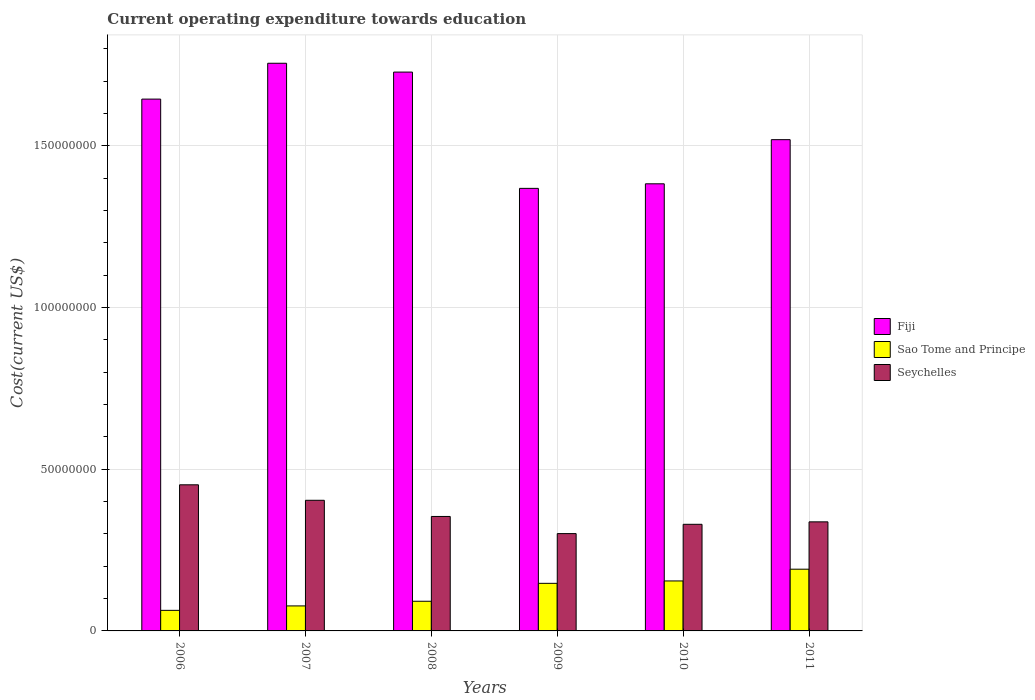How many different coloured bars are there?
Provide a succinct answer. 3. Are the number of bars per tick equal to the number of legend labels?
Your response must be concise. Yes. How many bars are there on the 1st tick from the left?
Give a very brief answer. 3. What is the expenditure towards education in Fiji in 2007?
Your answer should be compact. 1.76e+08. Across all years, what is the maximum expenditure towards education in Sao Tome and Principe?
Make the answer very short. 1.91e+07. Across all years, what is the minimum expenditure towards education in Fiji?
Keep it short and to the point. 1.37e+08. In which year was the expenditure towards education in Seychelles maximum?
Ensure brevity in your answer.  2006. In which year was the expenditure towards education in Seychelles minimum?
Provide a short and direct response. 2009. What is the total expenditure towards education in Seychelles in the graph?
Offer a terse response. 2.18e+08. What is the difference between the expenditure towards education in Fiji in 2006 and that in 2011?
Keep it short and to the point. 1.25e+07. What is the difference between the expenditure towards education in Seychelles in 2010 and the expenditure towards education in Fiji in 2009?
Offer a very short reply. -1.04e+08. What is the average expenditure towards education in Sao Tome and Principe per year?
Ensure brevity in your answer.  1.21e+07. In the year 2011, what is the difference between the expenditure towards education in Sao Tome and Principe and expenditure towards education in Fiji?
Offer a very short reply. -1.33e+08. In how many years, is the expenditure towards education in Seychelles greater than 100000000 US$?
Offer a very short reply. 0. What is the ratio of the expenditure towards education in Sao Tome and Principe in 2009 to that in 2011?
Offer a terse response. 0.77. Is the expenditure towards education in Seychelles in 2007 less than that in 2009?
Provide a succinct answer. No. Is the difference between the expenditure towards education in Sao Tome and Principe in 2007 and 2011 greater than the difference between the expenditure towards education in Fiji in 2007 and 2011?
Make the answer very short. No. What is the difference between the highest and the second highest expenditure towards education in Seychelles?
Ensure brevity in your answer.  4.79e+06. What is the difference between the highest and the lowest expenditure towards education in Sao Tome and Principe?
Offer a very short reply. 1.27e+07. In how many years, is the expenditure towards education in Fiji greater than the average expenditure towards education in Fiji taken over all years?
Ensure brevity in your answer.  3. What does the 3rd bar from the left in 2006 represents?
Offer a terse response. Seychelles. What does the 3rd bar from the right in 2009 represents?
Offer a very short reply. Fiji. Is it the case that in every year, the sum of the expenditure towards education in Seychelles and expenditure towards education in Sao Tome and Principe is greater than the expenditure towards education in Fiji?
Provide a short and direct response. No. Are all the bars in the graph horizontal?
Ensure brevity in your answer.  No. Does the graph contain any zero values?
Make the answer very short. No. Does the graph contain grids?
Offer a very short reply. Yes. Where does the legend appear in the graph?
Your response must be concise. Center right. How are the legend labels stacked?
Offer a very short reply. Vertical. What is the title of the graph?
Keep it short and to the point. Current operating expenditure towards education. What is the label or title of the Y-axis?
Offer a very short reply. Cost(current US$). What is the Cost(current US$) of Fiji in 2006?
Offer a very short reply. 1.64e+08. What is the Cost(current US$) of Sao Tome and Principe in 2006?
Provide a short and direct response. 6.36e+06. What is the Cost(current US$) in Seychelles in 2006?
Your response must be concise. 4.52e+07. What is the Cost(current US$) of Fiji in 2007?
Your answer should be compact. 1.76e+08. What is the Cost(current US$) of Sao Tome and Principe in 2007?
Ensure brevity in your answer.  7.73e+06. What is the Cost(current US$) of Seychelles in 2007?
Provide a short and direct response. 4.04e+07. What is the Cost(current US$) in Fiji in 2008?
Your answer should be very brief. 1.73e+08. What is the Cost(current US$) of Sao Tome and Principe in 2008?
Your answer should be very brief. 9.17e+06. What is the Cost(current US$) of Seychelles in 2008?
Give a very brief answer. 3.54e+07. What is the Cost(current US$) in Fiji in 2009?
Offer a very short reply. 1.37e+08. What is the Cost(current US$) in Sao Tome and Principe in 2009?
Offer a very short reply. 1.47e+07. What is the Cost(current US$) in Seychelles in 2009?
Offer a very short reply. 3.01e+07. What is the Cost(current US$) of Fiji in 2010?
Make the answer very short. 1.38e+08. What is the Cost(current US$) of Sao Tome and Principe in 2010?
Give a very brief answer. 1.55e+07. What is the Cost(current US$) in Seychelles in 2010?
Your response must be concise. 3.30e+07. What is the Cost(current US$) in Fiji in 2011?
Give a very brief answer. 1.52e+08. What is the Cost(current US$) of Sao Tome and Principe in 2011?
Ensure brevity in your answer.  1.91e+07. What is the Cost(current US$) of Seychelles in 2011?
Ensure brevity in your answer.  3.37e+07. Across all years, what is the maximum Cost(current US$) of Fiji?
Offer a terse response. 1.76e+08. Across all years, what is the maximum Cost(current US$) in Sao Tome and Principe?
Your response must be concise. 1.91e+07. Across all years, what is the maximum Cost(current US$) in Seychelles?
Offer a terse response. 4.52e+07. Across all years, what is the minimum Cost(current US$) of Fiji?
Your answer should be very brief. 1.37e+08. Across all years, what is the minimum Cost(current US$) of Sao Tome and Principe?
Make the answer very short. 6.36e+06. Across all years, what is the minimum Cost(current US$) of Seychelles?
Ensure brevity in your answer.  3.01e+07. What is the total Cost(current US$) in Fiji in the graph?
Provide a succinct answer. 9.40e+08. What is the total Cost(current US$) in Sao Tome and Principe in the graph?
Ensure brevity in your answer.  7.25e+07. What is the total Cost(current US$) of Seychelles in the graph?
Your response must be concise. 2.18e+08. What is the difference between the Cost(current US$) of Fiji in 2006 and that in 2007?
Your response must be concise. -1.11e+07. What is the difference between the Cost(current US$) in Sao Tome and Principe in 2006 and that in 2007?
Provide a short and direct response. -1.38e+06. What is the difference between the Cost(current US$) of Seychelles in 2006 and that in 2007?
Offer a terse response. 4.79e+06. What is the difference between the Cost(current US$) of Fiji in 2006 and that in 2008?
Your answer should be very brief. -8.36e+06. What is the difference between the Cost(current US$) in Sao Tome and Principe in 2006 and that in 2008?
Your answer should be compact. -2.81e+06. What is the difference between the Cost(current US$) in Seychelles in 2006 and that in 2008?
Keep it short and to the point. 9.79e+06. What is the difference between the Cost(current US$) in Fiji in 2006 and that in 2009?
Offer a terse response. 2.76e+07. What is the difference between the Cost(current US$) in Sao Tome and Principe in 2006 and that in 2009?
Your answer should be compact. -8.36e+06. What is the difference between the Cost(current US$) in Seychelles in 2006 and that in 2009?
Make the answer very short. 1.51e+07. What is the difference between the Cost(current US$) of Fiji in 2006 and that in 2010?
Give a very brief answer. 2.62e+07. What is the difference between the Cost(current US$) in Sao Tome and Principe in 2006 and that in 2010?
Offer a very short reply. -9.09e+06. What is the difference between the Cost(current US$) of Seychelles in 2006 and that in 2010?
Your response must be concise. 1.22e+07. What is the difference between the Cost(current US$) of Fiji in 2006 and that in 2011?
Keep it short and to the point. 1.25e+07. What is the difference between the Cost(current US$) in Sao Tome and Principe in 2006 and that in 2011?
Your answer should be very brief. -1.27e+07. What is the difference between the Cost(current US$) in Seychelles in 2006 and that in 2011?
Give a very brief answer. 1.15e+07. What is the difference between the Cost(current US$) in Fiji in 2007 and that in 2008?
Give a very brief answer. 2.73e+06. What is the difference between the Cost(current US$) in Sao Tome and Principe in 2007 and that in 2008?
Give a very brief answer. -1.44e+06. What is the difference between the Cost(current US$) of Seychelles in 2007 and that in 2008?
Offer a very short reply. 5.00e+06. What is the difference between the Cost(current US$) in Fiji in 2007 and that in 2009?
Keep it short and to the point. 3.87e+07. What is the difference between the Cost(current US$) in Sao Tome and Principe in 2007 and that in 2009?
Offer a very short reply. -6.98e+06. What is the difference between the Cost(current US$) in Seychelles in 2007 and that in 2009?
Offer a very short reply. 1.03e+07. What is the difference between the Cost(current US$) in Fiji in 2007 and that in 2010?
Your answer should be compact. 3.73e+07. What is the difference between the Cost(current US$) in Sao Tome and Principe in 2007 and that in 2010?
Provide a short and direct response. -7.72e+06. What is the difference between the Cost(current US$) of Seychelles in 2007 and that in 2010?
Give a very brief answer. 7.42e+06. What is the difference between the Cost(current US$) in Fiji in 2007 and that in 2011?
Your response must be concise. 2.36e+07. What is the difference between the Cost(current US$) in Sao Tome and Principe in 2007 and that in 2011?
Ensure brevity in your answer.  -1.14e+07. What is the difference between the Cost(current US$) of Seychelles in 2007 and that in 2011?
Keep it short and to the point. 6.67e+06. What is the difference between the Cost(current US$) in Fiji in 2008 and that in 2009?
Offer a very short reply. 3.60e+07. What is the difference between the Cost(current US$) in Sao Tome and Principe in 2008 and that in 2009?
Ensure brevity in your answer.  -5.54e+06. What is the difference between the Cost(current US$) of Seychelles in 2008 and that in 2009?
Give a very brief answer. 5.30e+06. What is the difference between the Cost(current US$) in Fiji in 2008 and that in 2010?
Keep it short and to the point. 3.45e+07. What is the difference between the Cost(current US$) of Sao Tome and Principe in 2008 and that in 2010?
Provide a short and direct response. -6.28e+06. What is the difference between the Cost(current US$) of Seychelles in 2008 and that in 2010?
Keep it short and to the point. 2.42e+06. What is the difference between the Cost(current US$) of Fiji in 2008 and that in 2011?
Offer a very short reply. 2.09e+07. What is the difference between the Cost(current US$) of Sao Tome and Principe in 2008 and that in 2011?
Provide a succinct answer. -9.92e+06. What is the difference between the Cost(current US$) of Seychelles in 2008 and that in 2011?
Give a very brief answer. 1.67e+06. What is the difference between the Cost(current US$) of Fiji in 2009 and that in 2010?
Ensure brevity in your answer.  -1.41e+06. What is the difference between the Cost(current US$) of Sao Tome and Principe in 2009 and that in 2010?
Your answer should be compact. -7.37e+05. What is the difference between the Cost(current US$) of Seychelles in 2009 and that in 2010?
Make the answer very short. -2.88e+06. What is the difference between the Cost(current US$) in Fiji in 2009 and that in 2011?
Provide a short and direct response. -1.51e+07. What is the difference between the Cost(current US$) of Sao Tome and Principe in 2009 and that in 2011?
Offer a very short reply. -4.37e+06. What is the difference between the Cost(current US$) of Seychelles in 2009 and that in 2011?
Offer a very short reply. -3.63e+06. What is the difference between the Cost(current US$) in Fiji in 2010 and that in 2011?
Provide a succinct answer. -1.36e+07. What is the difference between the Cost(current US$) of Sao Tome and Principe in 2010 and that in 2011?
Provide a succinct answer. -3.63e+06. What is the difference between the Cost(current US$) in Seychelles in 2010 and that in 2011?
Provide a succinct answer. -7.57e+05. What is the difference between the Cost(current US$) in Fiji in 2006 and the Cost(current US$) in Sao Tome and Principe in 2007?
Your response must be concise. 1.57e+08. What is the difference between the Cost(current US$) of Fiji in 2006 and the Cost(current US$) of Seychelles in 2007?
Provide a succinct answer. 1.24e+08. What is the difference between the Cost(current US$) of Sao Tome and Principe in 2006 and the Cost(current US$) of Seychelles in 2007?
Make the answer very short. -3.40e+07. What is the difference between the Cost(current US$) in Fiji in 2006 and the Cost(current US$) in Sao Tome and Principe in 2008?
Your response must be concise. 1.55e+08. What is the difference between the Cost(current US$) of Fiji in 2006 and the Cost(current US$) of Seychelles in 2008?
Keep it short and to the point. 1.29e+08. What is the difference between the Cost(current US$) of Sao Tome and Principe in 2006 and the Cost(current US$) of Seychelles in 2008?
Keep it short and to the point. -2.90e+07. What is the difference between the Cost(current US$) of Fiji in 2006 and the Cost(current US$) of Sao Tome and Principe in 2009?
Ensure brevity in your answer.  1.50e+08. What is the difference between the Cost(current US$) of Fiji in 2006 and the Cost(current US$) of Seychelles in 2009?
Your response must be concise. 1.34e+08. What is the difference between the Cost(current US$) in Sao Tome and Principe in 2006 and the Cost(current US$) in Seychelles in 2009?
Give a very brief answer. -2.37e+07. What is the difference between the Cost(current US$) in Fiji in 2006 and the Cost(current US$) in Sao Tome and Principe in 2010?
Ensure brevity in your answer.  1.49e+08. What is the difference between the Cost(current US$) in Fiji in 2006 and the Cost(current US$) in Seychelles in 2010?
Offer a very short reply. 1.31e+08. What is the difference between the Cost(current US$) of Sao Tome and Principe in 2006 and the Cost(current US$) of Seychelles in 2010?
Offer a very short reply. -2.66e+07. What is the difference between the Cost(current US$) of Fiji in 2006 and the Cost(current US$) of Sao Tome and Principe in 2011?
Your answer should be compact. 1.45e+08. What is the difference between the Cost(current US$) of Fiji in 2006 and the Cost(current US$) of Seychelles in 2011?
Ensure brevity in your answer.  1.31e+08. What is the difference between the Cost(current US$) in Sao Tome and Principe in 2006 and the Cost(current US$) in Seychelles in 2011?
Ensure brevity in your answer.  -2.74e+07. What is the difference between the Cost(current US$) in Fiji in 2007 and the Cost(current US$) in Sao Tome and Principe in 2008?
Make the answer very short. 1.66e+08. What is the difference between the Cost(current US$) of Fiji in 2007 and the Cost(current US$) of Seychelles in 2008?
Your answer should be very brief. 1.40e+08. What is the difference between the Cost(current US$) in Sao Tome and Principe in 2007 and the Cost(current US$) in Seychelles in 2008?
Keep it short and to the point. -2.77e+07. What is the difference between the Cost(current US$) of Fiji in 2007 and the Cost(current US$) of Sao Tome and Principe in 2009?
Provide a short and direct response. 1.61e+08. What is the difference between the Cost(current US$) of Fiji in 2007 and the Cost(current US$) of Seychelles in 2009?
Make the answer very short. 1.45e+08. What is the difference between the Cost(current US$) in Sao Tome and Principe in 2007 and the Cost(current US$) in Seychelles in 2009?
Ensure brevity in your answer.  -2.24e+07. What is the difference between the Cost(current US$) in Fiji in 2007 and the Cost(current US$) in Sao Tome and Principe in 2010?
Your answer should be compact. 1.60e+08. What is the difference between the Cost(current US$) of Fiji in 2007 and the Cost(current US$) of Seychelles in 2010?
Keep it short and to the point. 1.43e+08. What is the difference between the Cost(current US$) in Sao Tome and Principe in 2007 and the Cost(current US$) in Seychelles in 2010?
Your answer should be very brief. -2.52e+07. What is the difference between the Cost(current US$) of Fiji in 2007 and the Cost(current US$) of Sao Tome and Principe in 2011?
Your answer should be compact. 1.56e+08. What is the difference between the Cost(current US$) of Fiji in 2007 and the Cost(current US$) of Seychelles in 2011?
Your answer should be compact. 1.42e+08. What is the difference between the Cost(current US$) in Sao Tome and Principe in 2007 and the Cost(current US$) in Seychelles in 2011?
Offer a terse response. -2.60e+07. What is the difference between the Cost(current US$) in Fiji in 2008 and the Cost(current US$) in Sao Tome and Principe in 2009?
Provide a short and direct response. 1.58e+08. What is the difference between the Cost(current US$) in Fiji in 2008 and the Cost(current US$) in Seychelles in 2009?
Offer a terse response. 1.43e+08. What is the difference between the Cost(current US$) in Sao Tome and Principe in 2008 and the Cost(current US$) in Seychelles in 2009?
Ensure brevity in your answer.  -2.09e+07. What is the difference between the Cost(current US$) in Fiji in 2008 and the Cost(current US$) in Sao Tome and Principe in 2010?
Offer a terse response. 1.57e+08. What is the difference between the Cost(current US$) of Fiji in 2008 and the Cost(current US$) of Seychelles in 2010?
Offer a terse response. 1.40e+08. What is the difference between the Cost(current US$) of Sao Tome and Principe in 2008 and the Cost(current US$) of Seychelles in 2010?
Ensure brevity in your answer.  -2.38e+07. What is the difference between the Cost(current US$) of Fiji in 2008 and the Cost(current US$) of Sao Tome and Principe in 2011?
Give a very brief answer. 1.54e+08. What is the difference between the Cost(current US$) in Fiji in 2008 and the Cost(current US$) in Seychelles in 2011?
Your answer should be compact. 1.39e+08. What is the difference between the Cost(current US$) of Sao Tome and Principe in 2008 and the Cost(current US$) of Seychelles in 2011?
Provide a short and direct response. -2.46e+07. What is the difference between the Cost(current US$) of Fiji in 2009 and the Cost(current US$) of Sao Tome and Principe in 2010?
Your answer should be very brief. 1.21e+08. What is the difference between the Cost(current US$) of Fiji in 2009 and the Cost(current US$) of Seychelles in 2010?
Ensure brevity in your answer.  1.04e+08. What is the difference between the Cost(current US$) of Sao Tome and Principe in 2009 and the Cost(current US$) of Seychelles in 2010?
Your answer should be very brief. -1.83e+07. What is the difference between the Cost(current US$) of Fiji in 2009 and the Cost(current US$) of Sao Tome and Principe in 2011?
Provide a succinct answer. 1.18e+08. What is the difference between the Cost(current US$) in Fiji in 2009 and the Cost(current US$) in Seychelles in 2011?
Provide a short and direct response. 1.03e+08. What is the difference between the Cost(current US$) in Sao Tome and Principe in 2009 and the Cost(current US$) in Seychelles in 2011?
Keep it short and to the point. -1.90e+07. What is the difference between the Cost(current US$) in Fiji in 2010 and the Cost(current US$) in Sao Tome and Principe in 2011?
Your answer should be compact. 1.19e+08. What is the difference between the Cost(current US$) of Fiji in 2010 and the Cost(current US$) of Seychelles in 2011?
Your response must be concise. 1.05e+08. What is the difference between the Cost(current US$) in Sao Tome and Principe in 2010 and the Cost(current US$) in Seychelles in 2011?
Provide a succinct answer. -1.83e+07. What is the average Cost(current US$) of Fiji per year?
Provide a succinct answer. 1.57e+08. What is the average Cost(current US$) of Sao Tome and Principe per year?
Offer a terse response. 1.21e+07. What is the average Cost(current US$) of Seychelles per year?
Give a very brief answer. 3.63e+07. In the year 2006, what is the difference between the Cost(current US$) in Fiji and Cost(current US$) in Sao Tome and Principe?
Your response must be concise. 1.58e+08. In the year 2006, what is the difference between the Cost(current US$) of Fiji and Cost(current US$) of Seychelles?
Offer a very short reply. 1.19e+08. In the year 2006, what is the difference between the Cost(current US$) of Sao Tome and Principe and Cost(current US$) of Seychelles?
Make the answer very short. -3.88e+07. In the year 2007, what is the difference between the Cost(current US$) in Fiji and Cost(current US$) in Sao Tome and Principe?
Your answer should be very brief. 1.68e+08. In the year 2007, what is the difference between the Cost(current US$) in Fiji and Cost(current US$) in Seychelles?
Your answer should be very brief. 1.35e+08. In the year 2007, what is the difference between the Cost(current US$) of Sao Tome and Principe and Cost(current US$) of Seychelles?
Your answer should be very brief. -3.27e+07. In the year 2008, what is the difference between the Cost(current US$) in Fiji and Cost(current US$) in Sao Tome and Principe?
Your answer should be compact. 1.64e+08. In the year 2008, what is the difference between the Cost(current US$) in Fiji and Cost(current US$) in Seychelles?
Your response must be concise. 1.37e+08. In the year 2008, what is the difference between the Cost(current US$) in Sao Tome and Principe and Cost(current US$) in Seychelles?
Offer a very short reply. -2.62e+07. In the year 2009, what is the difference between the Cost(current US$) in Fiji and Cost(current US$) in Sao Tome and Principe?
Make the answer very short. 1.22e+08. In the year 2009, what is the difference between the Cost(current US$) of Fiji and Cost(current US$) of Seychelles?
Make the answer very short. 1.07e+08. In the year 2009, what is the difference between the Cost(current US$) of Sao Tome and Principe and Cost(current US$) of Seychelles?
Ensure brevity in your answer.  -1.54e+07. In the year 2010, what is the difference between the Cost(current US$) of Fiji and Cost(current US$) of Sao Tome and Principe?
Give a very brief answer. 1.23e+08. In the year 2010, what is the difference between the Cost(current US$) in Fiji and Cost(current US$) in Seychelles?
Your answer should be compact. 1.05e+08. In the year 2010, what is the difference between the Cost(current US$) in Sao Tome and Principe and Cost(current US$) in Seychelles?
Provide a short and direct response. -1.75e+07. In the year 2011, what is the difference between the Cost(current US$) in Fiji and Cost(current US$) in Sao Tome and Principe?
Keep it short and to the point. 1.33e+08. In the year 2011, what is the difference between the Cost(current US$) of Fiji and Cost(current US$) of Seychelles?
Keep it short and to the point. 1.18e+08. In the year 2011, what is the difference between the Cost(current US$) of Sao Tome and Principe and Cost(current US$) of Seychelles?
Keep it short and to the point. -1.46e+07. What is the ratio of the Cost(current US$) of Fiji in 2006 to that in 2007?
Your answer should be very brief. 0.94. What is the ratio of the Cost(current US$) of Sao Tome and Principe in 2006 to that in 2007?
Provide a short and direct response. 0.82. What is the ratio of the Cost(current US$) in Seychelles in 2006 to that in 2007?
Make the answer very short. 1.12. What is the ratio of the Cost(current US$) of Fiji in 2006 to that in 2008?
Make the answer very short. 0.95. What is the ratio of the Cost(current US$) of Sao Tome and Principe in 2006 to that in 2008?
Your answer should be compact. 0.69. What is the ratio of the Cost(current US$) in Seychelles in 2006 to that in 2008?
Ensure brevity in your answer.  1.28. What is the ratio of the Cost(current US$) of Fiji in 2006 to that in 2009?
Keep it short and to the point. 1.2. What is the ratio of the Cost(current US$) in Sao Tome and Principe in 2006 to that in 2009?
Provide a short and direct response. 0.43. What is the ratio of the Cost(current US$) in Seychelles in 2006 to that in 2009?
Ensure brevity in your answer.  1.5. What is the ratio of the Cost(current US$) of Fiji in 2006 to that in 2010?
Your response must be concise. 1.19. What is the ratio of the Cost(current US$) of Sao Tome and Principe in 2006 to that in 2010?
Your answer should be compact. 0.41. What is the ratio of the Cost(current US$) of Seychelles in 2006 to that in 2010?
Your answer should be compact. 1.37. What is the ratio of the Cost(current US$) of Fiji in 2006 to that in 2011?
Offer a very short reply. 1.08. What is the ratio of the Cost(current US$) of Sao Tome and Principe in 2006 to that in 2011?
Offer a very short reply. 0.33. What is the ratio of the Cost(current US$) of Seychelles in 2006 to that in 2011?
Give a very brief answer. 1.34. What is the ratio of the Cost(current US$) of Fiji in 2007 to that in 2008?
Your response must be concise. 1.02. What is the ratio of the Cost(current US$) of Sao Tome and Principe in 2007 to that in 2008?
Offer a very short reply. 0.84. What is the ratio of the Cost(current US$) of Seychelles in 2007 to that in 2008?
Offer a terse response. 1.14. What is the ratio of the Cost(current US$) of Fiji in 2007 to that in 2009?
Keep it short and to the point. 1.28. What is the ratio of the Cost(current US$) of Sao Tome and Principe in 2007 to that in 2009?
Provide a short and direct response. 0.53. What is the ratio of the Cost(current US$) of Seychelles in 2007 to that in 2009?
Ensure brevity in your answer.  1.34. What is the ratio of the Cost(current US$) of Fiji in 2007 to that in 2010?
Make the answer very short. 1.27. What is the ratio of the Cost(current US$) of Sao Tome and Principe in 2007 to that in 2010?
Offer a terse response. 0.5. What is the ratio of the Cost(current US$) of Seychelles in 2007 to that in 2010?
Provide a succinct answer. 1.23. What is the ratio of the Cost(current US$) in Fiji in 2007 to that in 2011?
Provide a short and direct response. 1.16. What is the ratio of the Cost(current US$) of Sao Tome and Principe in 2007 to that in 2011?
Your response must be concise. 0.41. What is the ratio of the Cost(current US$) in Seychelles in 2007 to that in 2011?
Ensure brevity in your answer.  1.2. What is the ratio of the Cost(current US$) of Fiji in 2008 to that in 2009?
Your answer should be compact. 1.26. What is the ratio of the Cost(current US$) in Sao Tome and Principe in 2008 to that in 2009?
Offer a very short reply. 0.62. What is the ratio of the Cost(current US$) in Seychelles in 2008 to that in 2009?
Give a very brief answer. 1.18. What is the ratio of the Cost(current US$) in Fiji in 2008 to that in 2010?
Keep it short and to the point. 1.25. What is the ratio of the Cost(current US$) of Sao Tome and Principe in 2008 to that in 2010?
Your answer should be very brief. 0.59. What is the ratio of the Cost(current US$) in Seychelles in 2008 to that in 2010?
Provide a short and direct response. 1.07. What is the ratio of the Cost(current US$) in Fiji in 2008 to that in 2011?
Make the answer very short. 1.14. What is the ratio of the Cost(current US$) of Sao Tome and Principe in 2008 to that in 2011?
Keep it short and to the point. 0.48. What is the ratio of the Cost(current US$) in Seychelles in 2008 to that in 2011?
Your answer should be compact. 1.05. What is the ratio of the Cost(current US$) of Sao Tome and Principe in 2009 to that in 2010?
Offer a terse response. 0.95. What is the ratio of the Cost(current US$) in Seychelles in 2009 to that in 2010?
Ensure brevity in your answer.  0.91. What is the ratio of the Cost(current US$) of Fiji in 2009 to that in 2011?
Offer a terse response. 0.9. What is the ratio of the Cost(current US$) of Sao Tome and Principe in 2009 to that in 2011?
Give a very brief answer. 0.77. What is the ratio of the Cost(current US$) in Seychelles in 2009 to that in 2011?
Offer a very short reply. 0.89. What is the ratio of the Cost(current US$) of Fiji in 2010 to that in 2011?
Provide a succinct answer. 0.91. What is the ratio of the Cost(current US$) of Sao Tome and Principe in 2010 to that in 2011?
Offer a very short reply. 0.81. What is the ratio of the Cost(current US$) of Seychelles in 2010 to that in 2011?
Provide a succinct answer. 0.98. What is the difference between the highest and the second highest Cost(current US$) of Fiji?
Your answer should be very brief. 2.73e+06. What is the difference between the highest and the second highest Cost(current US$) of Sao Tome and Principe?
Offer a terse response. 3.63e+06. What is the difference between the highest and the second highest Cost(current US$) in Seychelles?
Offer a very short reply. 4.79e+06. What is the difference between the highest and the lowest Cost(current US$) in Fiji?
Offer a terse response. 3.87e+07. What is the difference between the highest and the lowest Cost(current US$) of Sao Tome and Principe?
Keep it short and to the point. 1.27e+07. What is the difference between the highest and the lowest Cost(current US$) of Seychelles?
Provide a succinct answer. 1.51e+07. 